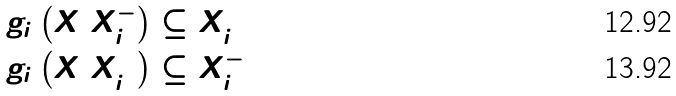Convert formula to latex. <formula><loc_0><loc_0><loc_500><loc_500>& g _ { i } \left ( X \ X _ { i } ^ { - } \right ) \subseteq X _ { i } ^ { + } \\ & g _ { i } \left ( X \ X _ { i } ^ { + } \right ) \subseteq X _ { i } ^ { - }</formula> 